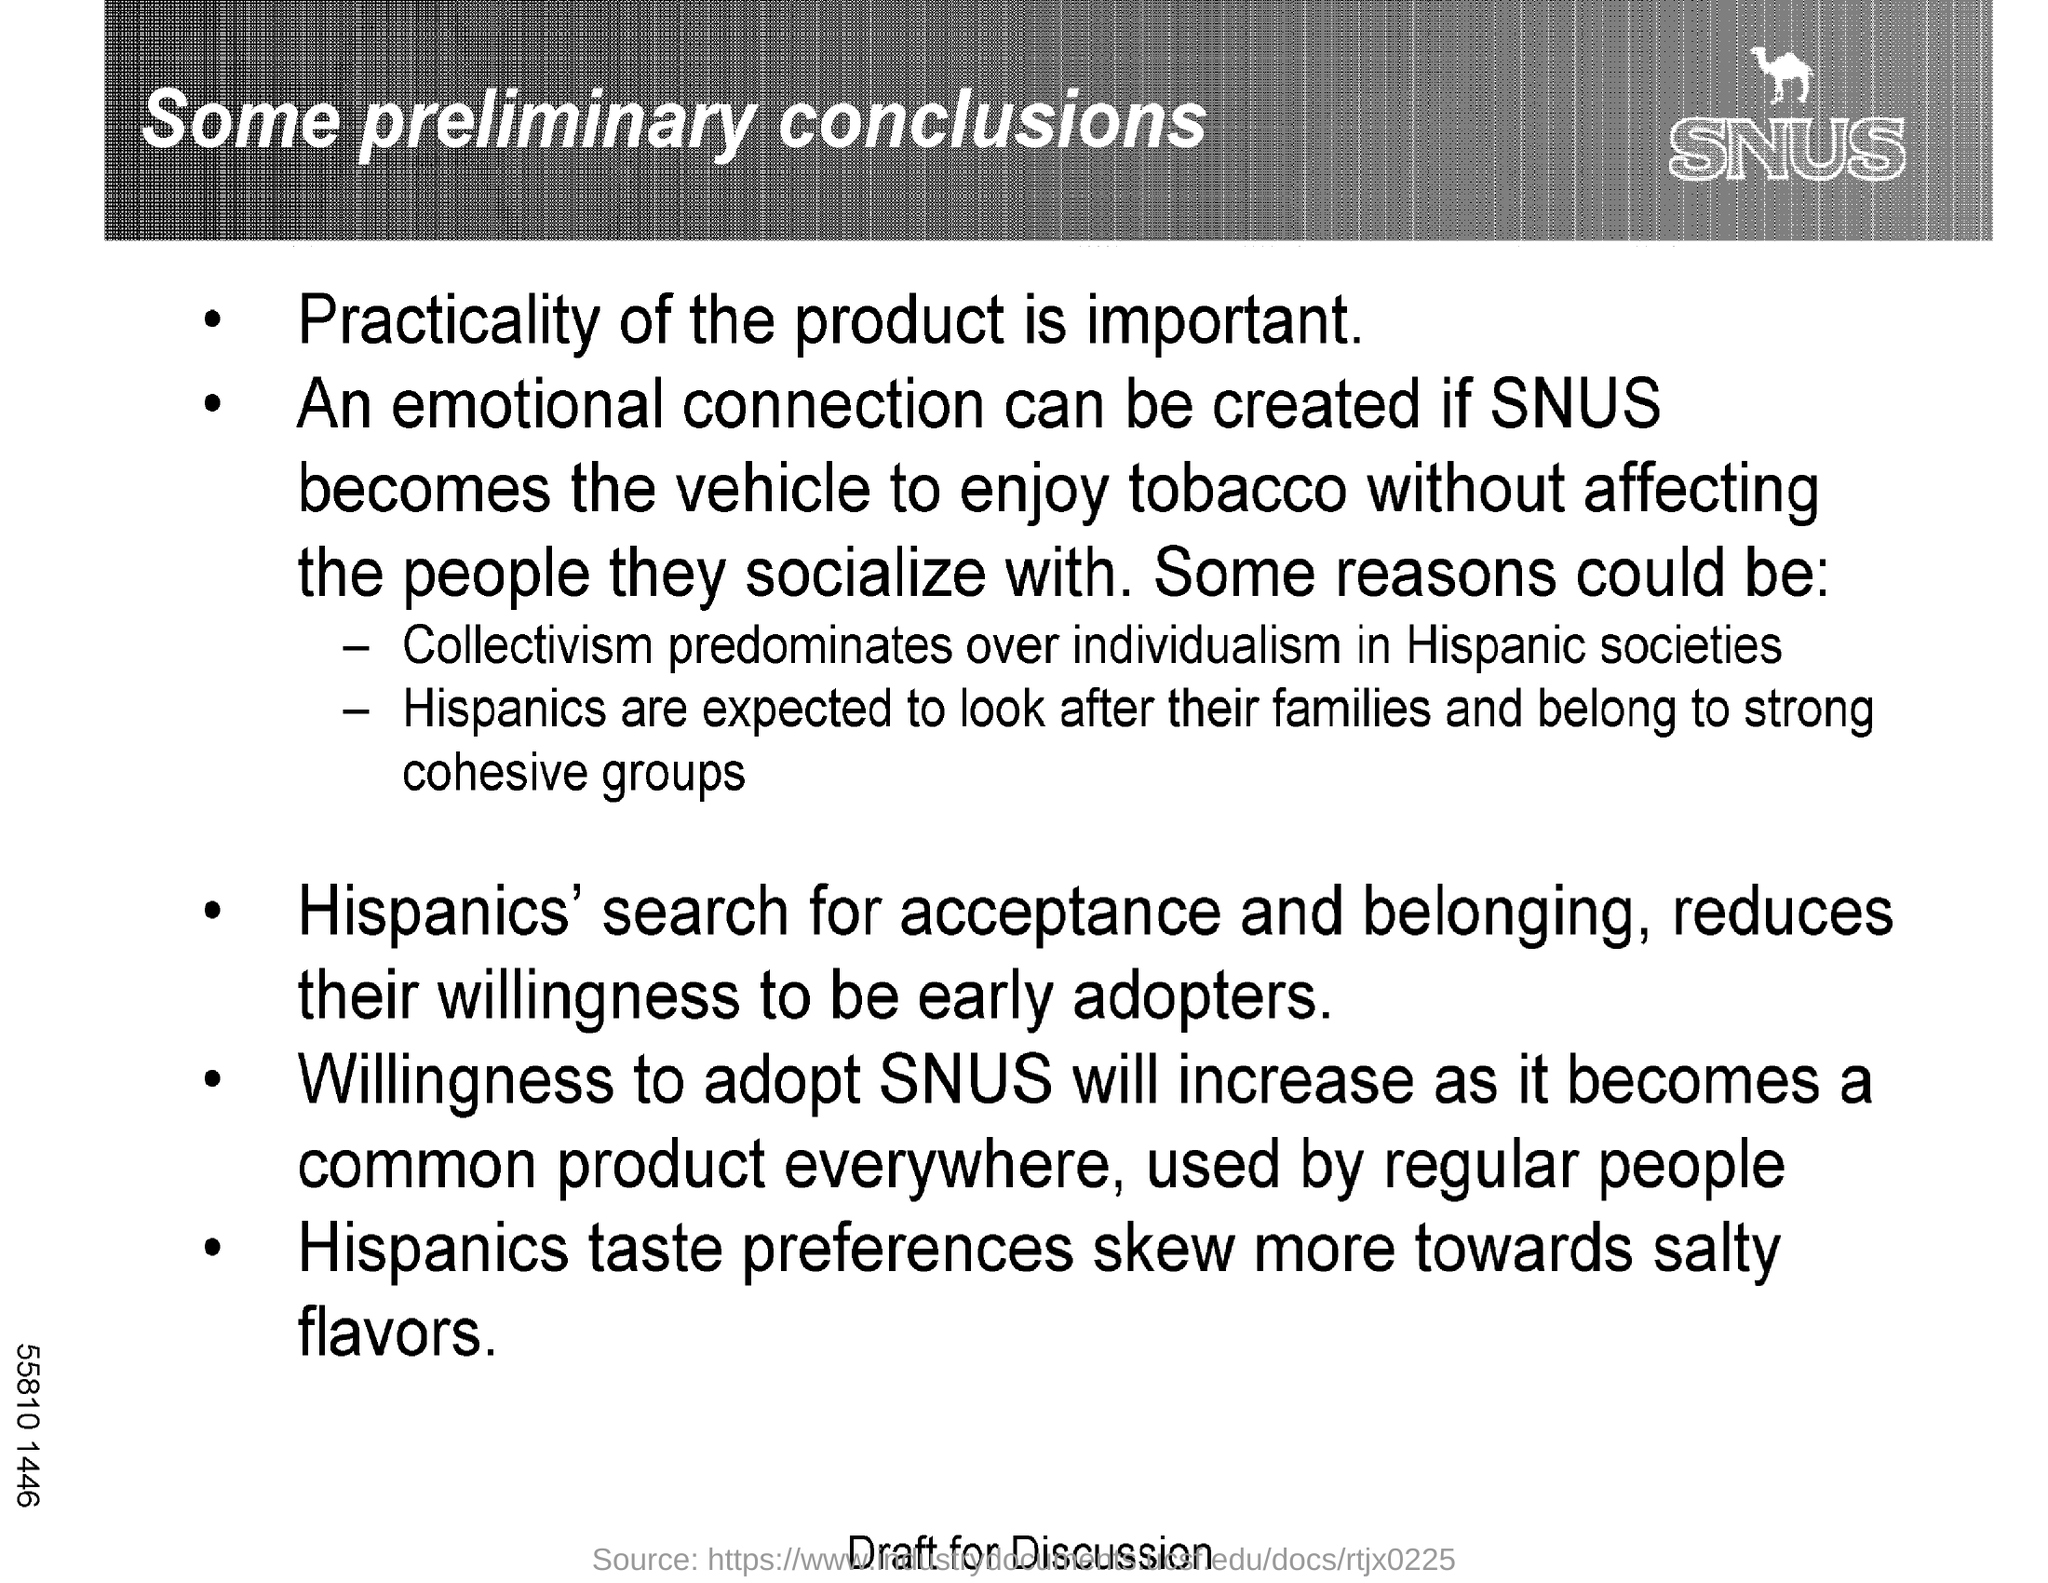Highlight a few significant elements in this photo. Hispanics typically prefer salty flavors. The title of this document is 'Some Preliminary Conclusions'. 